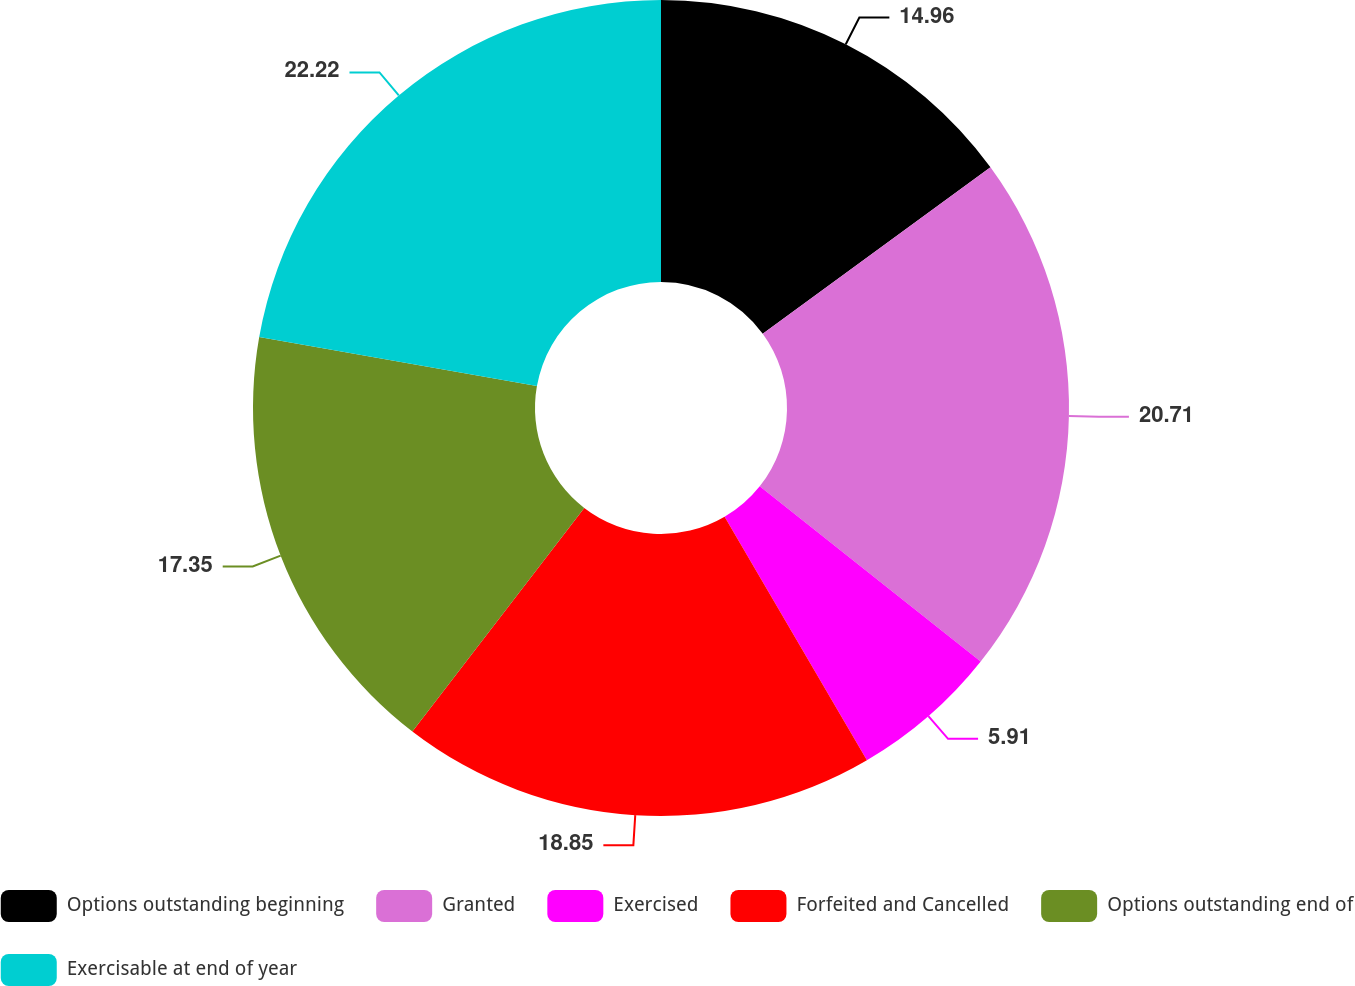Convert chart to OTSL. <chart><loc_0><loc_0><loc_500><loc_500><pie_chart><fcel>Options outstanding beginning<fcel>Granted<fcel>Exercised<fcel>Forfeited and Cancelled<fcel>Options outstanding end of<fcel>Exercisable at end of year<nl><fcel>14.96%<fcel>20.71%<fcel>5.91%<fcel>18.85%<fcel>17.35%<fcel>22.22%<nl></chart> 